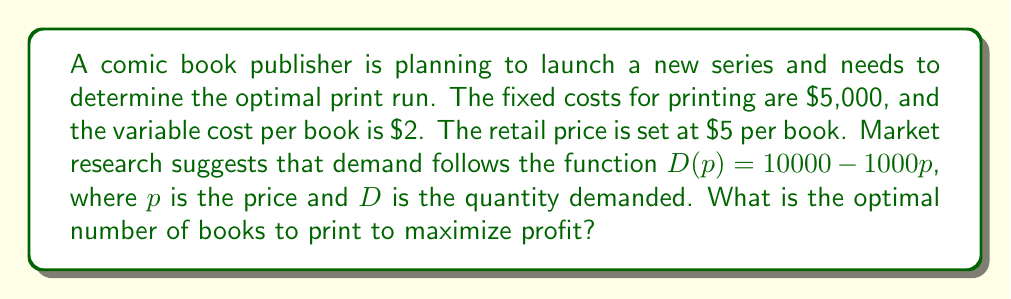Can you answer this question? To solve this problem, we'll use cost-benefit analysis and optimization techniques:

1. Define the profit function:
   Profit = Revenue - Costs
   $\Pi = pQ - (FC + vcQ)$
   Where:
   $\Pi$ = Profit
   $p$ = Price ($5)
   $Q$ = Quantity
   $FC$ = Fixed Costs ($5,000)
   $vc$ = Variable Cost per unit ($2)

2. Substitute the given values:
   $\Pi = 5Q - (5000 + 2Q)$
   $\Pi = 5Q - 5000 - 2Q$
   $\Pi = 3Q - 5000$

3. Use the demand function to express Q in terms of p:
   $Q = D(p) = 10000 - 1000p$
   At $p = 5$: $Q = 10000 - 1000(5) = 5000$

4. Substitute Q into the profit function:
   $\Pi = 3(5000) - 5000$
   $\Pi = 15000 - 5000 = 10000$

5. The optimal print run is the quantity that maximizes profit, which in this case is the same as the quantity demanded at the given price.
Answer: The optimal print run is 5,000 books. 